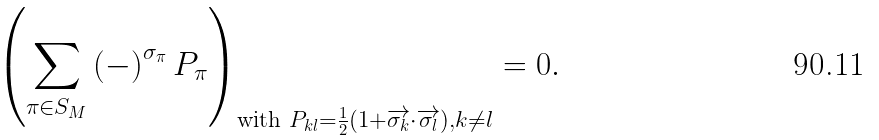Convert formula to latex. <formula><loc_0><loc_0><loc_500><loc_500>\left ( \sum _ { \pi \in S _ { M } } \left ( - \right ) ^ { \sigma _ { \pi } } P _ { \pi } \right ) _ { \text {with } P _ { k l } = \frac { 1 } { 2 } \left ( 1 + \overrightarrow { \sigma _ { k } } \cdot \overrightarrow { \sigma _ { l } } \right ) , k \neq l } = 0 .</formula> 